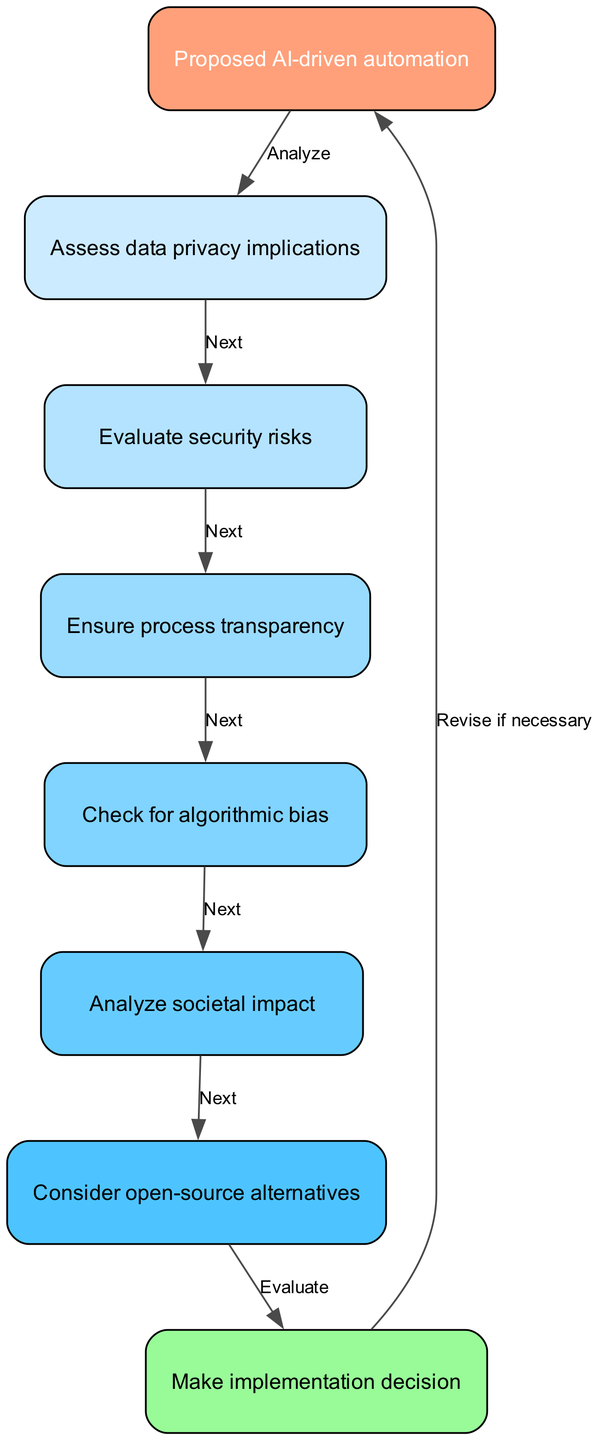What is the first step in the automation process? The first step in the process is the node labeled "Proposed AI-driven automation." This node initiates the flowchart and serves as the starting point for analyzing the implementation of AI-driven automation.
Answer: Proposed AI-driven automation How many nodes are there in total? Counting all the unique nodes listed in the diagram, there are eight nodes: Proposed AI-driven automation, Assess data privacy implications, Evaluate security risks, Ensure process transparency, Check for algorithmic bias, Analyze societal impact, Consider open-source alternatives, and Make implementation decision. Thus, the total number of nodes is eight.
Answer: Eight What does the "Assess data privacy implications" node lead to next? The "Assess data privacy implications" node has an edge labeled "Next" that directs the flowchart to the "Evaluate security risks" node. This demonstrates that after assessing data privacy, the next immediate step is to evaluate security risks.
Answer: Evaluate security risks What is the final action taken before making an implementation decision? The final action before making an implementation decision is to "Consider open-source alternatives." This is the last assessment in the flow before arriving at the final decision point in the chart.
Answer: Consider open-source alternatives Which node checks for algorithmic bias? The node that specifically checks for algorithmic bias is labeled "Check for algorithmic bias." This indicates a dedicated assessment stage that evaluates any potential biases present in the algorithms being utilized for automation.
Answer: Check for algorithmic bias What happens if the decision to implement needs revisions? If the decision to implement the automation process needs revisions, the flowchart indicates to "Revise if necessary," which means that the process can loop back to the starting point for further assessment and refinement based on the findings.
Answer: Revise if necessary How many edges connect the nodes in this diagram? To find the total number of edges, we count each unique connection from one node to another based on the edges provided. There are seven edges in total connecting the nodes.
Answer: Seven What is the purpose of the "Ensure process transparency" node? The purpose of the "Ensure process transparency" node is to guarantee that the automation process is clear and open, which is essential for ethical AI implementation. This step follows evaluating security risks, indicating its importance in the decision-making process.
Answer: Ensure process transparency 